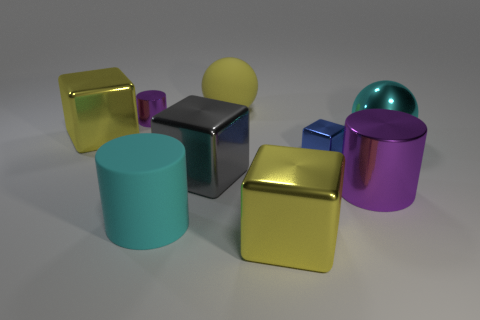There is a sphere that is the same material as the big cyan cylinder; what is its color? The sphere that appears to share the material with the large cyan cylinder has a yellow color, which can be inferred by observing the matching reflective properties and color tone between the two objects. 